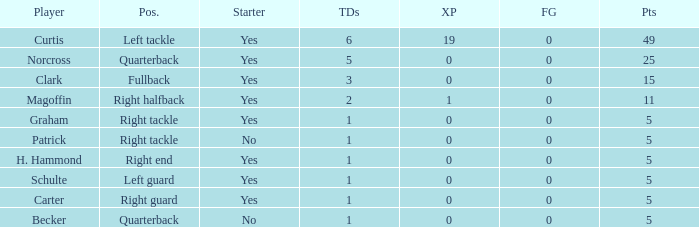Name the extra points for left guard 0.0. 